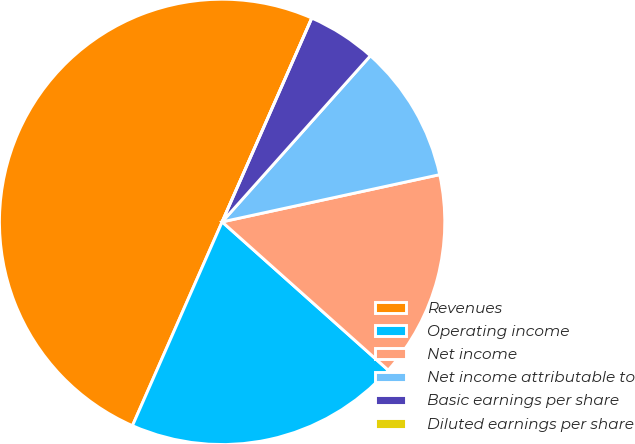Convert chart. <chart><loc_0><loc_0><loc_500><loc_500><pie_chart><fcel>Revenues<fcel>Operating income<fcel>Net income<fcel>Net income attributable to<fcel>Basic earnings per share<fcel>Diluted earnings per share<nl><fcel>50.0%<fcel>20.0%<fcel>15.0%<fcel>10.0%<fcel>5.0%<fcel>0.0%<nl></chart> 